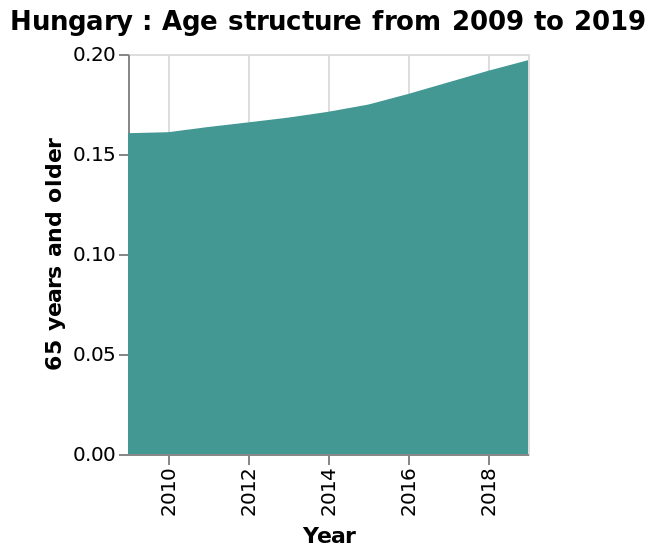<image>
Which years are shown on the x-axis for the age structure plot in Hungary? The years 2010 to 2018 are shown on the x-axis for the age structure plot in Hungary. 